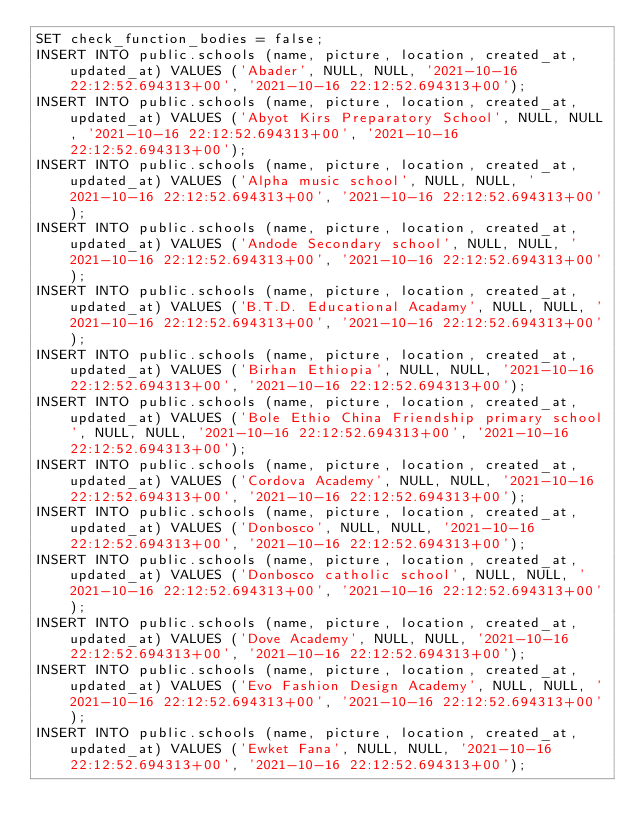Convert code to text. <code><loc_0><loc_0><loc_500><loc_500><_SQL_>SET check_function_bodies = false;
INSERT INTO public.schools (name, picture, location, created_at, updated_at) VALUES ('Abader', NULL, NULL, '2021-10-16 22:12:52.694313+00', '2021-10-16 22:12:52.694313+00');
INSERT INTO public.schools (name, picture, location, created_at, updated_at) VALUES ('Abyot Kirs Preparatory School', NULL, NULL, '2021-10-16 22:12:52.694313+00', '2021-10-16 22:12:52.694313+00');
INSERT INTO public.schools (name, picture, location, created_at, updated_at) VALUES ('Alpha music school', NULL, NULL, '2021-10-16 22:12:52.694313+00', '2021-10-16 22:12:52.694313+00');
INSERT INTO public.schools (name, picture, location, created_at, updated_at) VALUES ('Andode Secondary school', NULL, NULL, '2021-10-16 22:12:52.694313+00', '2021-10-16 22:12:52.694313+00');
INSERT INTO public.schools (name, picture, location, created_at, updated_at) VALUES ('B.T.D. Educational Acadamy', NULL, NULL, '2021-10-16 22:12:52.694313+00', '2021-10-16 22:12:52.694313+00');
INSERT INTO public.schools (name, picture, location, created_at, updated_at) VALUES ('Birhan Ethiopia', NULL, NULL, '2021-10-16 22:12:52.694313+00', '2021-10-16 22:12:52.694313+00');
INSERT INTO public.schools (name, picture, location, created_at, updated_at) VALUES ('Bole Ethio China Friendship primary school', NULL, NULL, '2021-10-16 22:12:52.694313+00', '2021-10-16 22:12:52.694313+00');
INSERT INTO public.schools (name, picture, location, created_at, updated_at) VALUES ('Cordova Academy', NULL, NULL, '2021-10-16 22:12:52.694313+00', '2021-10-16 22:12:52.694313+00');
INSERT INTO public.schools (name, picture, location, created_at, updated_at) VALUES ('Donbosco', NULL, NULL, '2021-10-16 22:12:52.694313+00', '2021-10-16 22:12:52.694313+00');
INSERT INTO public.schools (name, picture, location, created_at, updated_at) VALUES ('Donbosco catholic school', NULL, NULL, '2021-10-16 22:12:52.694313+00', '2021-10-16 22:12:52.694313+00');
INSERT INTO public.schools (name, picture, location, created_at, updated_at) VALUES ('Dove Academy', NULL, NULL, '2021-10-16 22:12:52.694313+00', '2021-10-16 22:12:52.694313+00');
INSERT INTO public.schools (name, picture, location, created_at, updated_at) VALUES ('Evo Fashion Design Academy', NULL, NULL, '2021-10-16 22:12:52.694313+00', '2021-10-16 22:12:52.694313+00');
INSERT INTO public.schools (name, picture, location, created_at, updated_at) VALUES ('Ewket Fana', NULL, NULL, '2021-10-16 22:12:52.694313+00', '2021-10-16 22:12:52.694313+00');</code> 